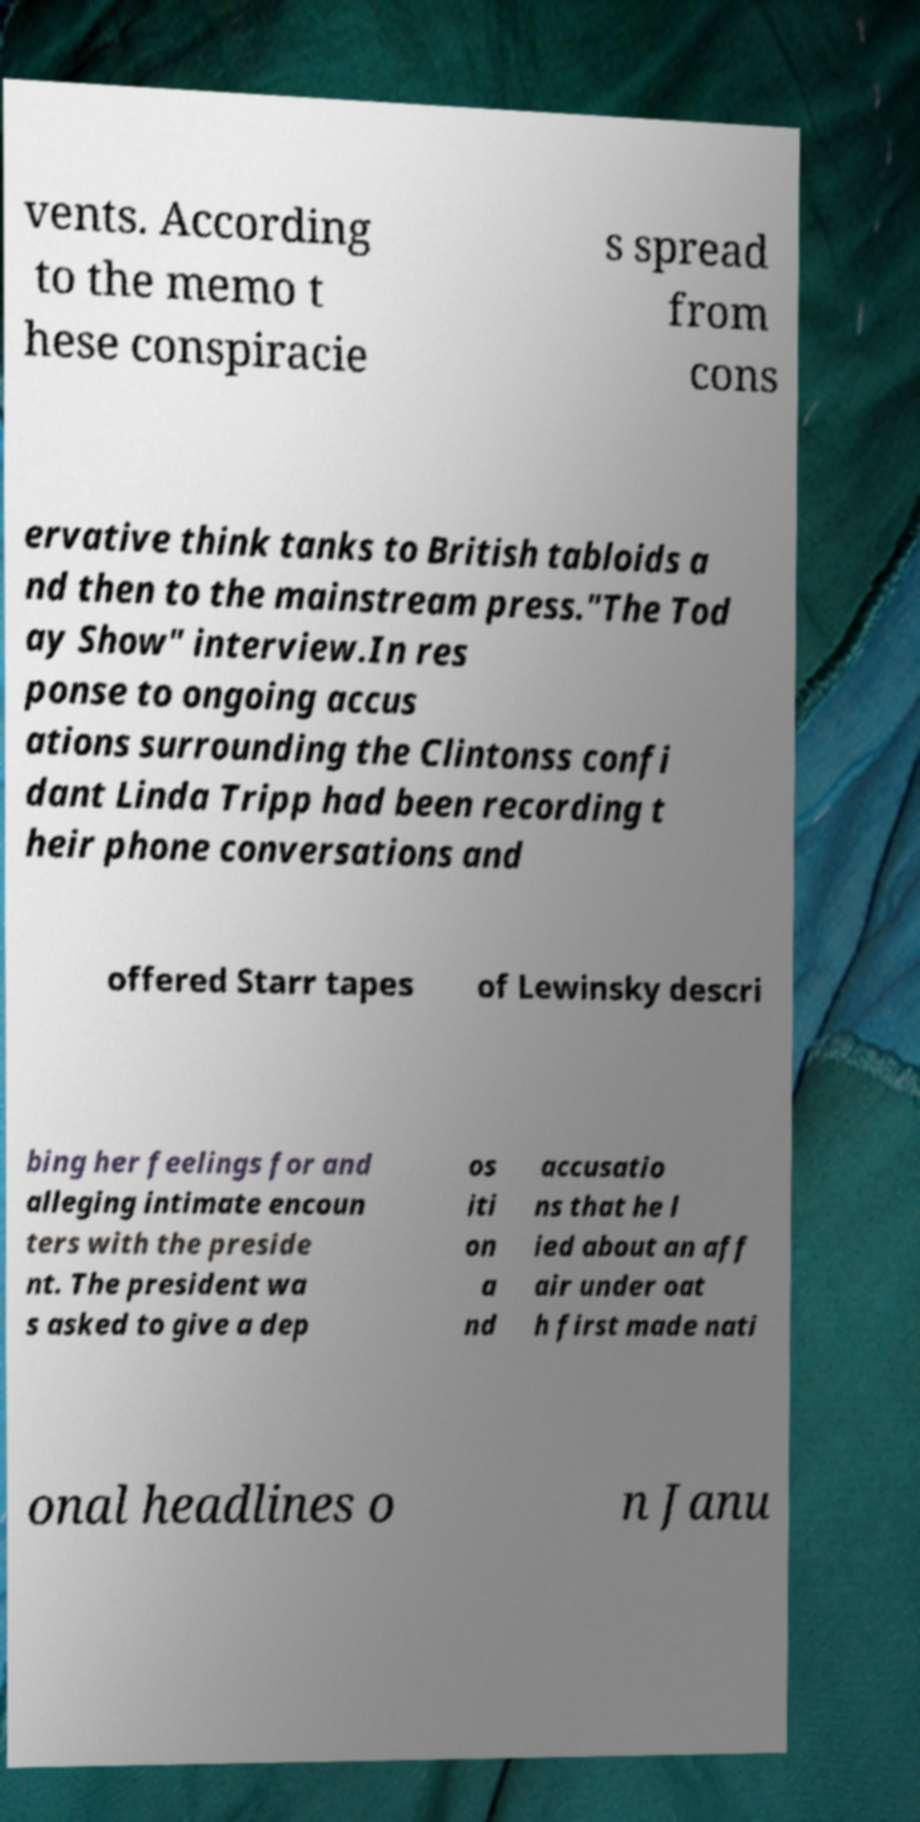Please read and relay the text visible in this image. What does it say? vents. According to the memo t hese conspiracie s spread from cons ervative think tanks to British tabloids a nd then to the mainstream press."The Tod ay Show" interview.In res ponse to ongoing accus ations surrounding the Clintonss confi dant Linda Tripp had been recording t heir phone conversations and offered Starr tapes of Lewinsky descri bing her feelings for and alleging intimate encoun ters with the preside nt. The president wa s asked to give a dep os iti on a nd accusatio ns that he l ied about an aff air under oat h first made nati onal headlines o n Janu 